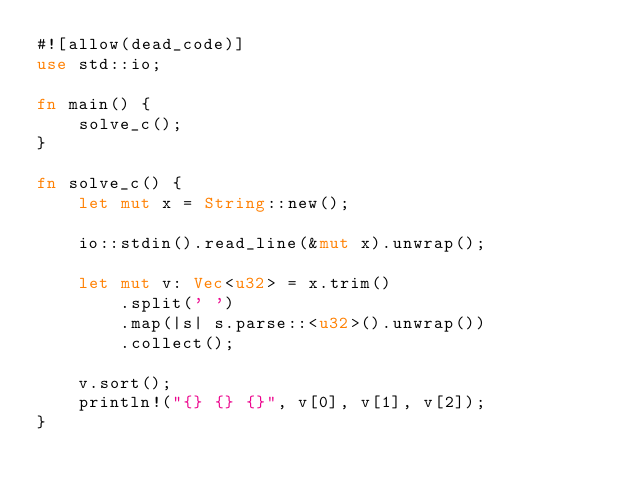<code> <loc_0><loc_0><loc_500><loc_500><_Rust_>#![allow(dead_code)]
use std::io;

fn main() {
    solve_c();
}

fn solve_c() {
    let mut x = String::new();

    io::stdin().read_line(&mut x).unwrap();

    let mut v: Vec<u32> = x.trim()
        .split(' ')
        .map(|s| s.parse::<u32>().unwrap())
        .collect();

    v.sort();
    println!("{} {} {}", v[0], v[1], v[2]);
}

</code> 